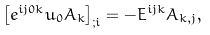Convert formula to latex. <formula><loc_0><loc_0><loc_500><loc_500>\left [ e ^ { i j 0 k } u _ { 0 } A _ { k } \right ] _ { ; i } = - E ^ { i j k } A _ { k , j } ,</formula> 